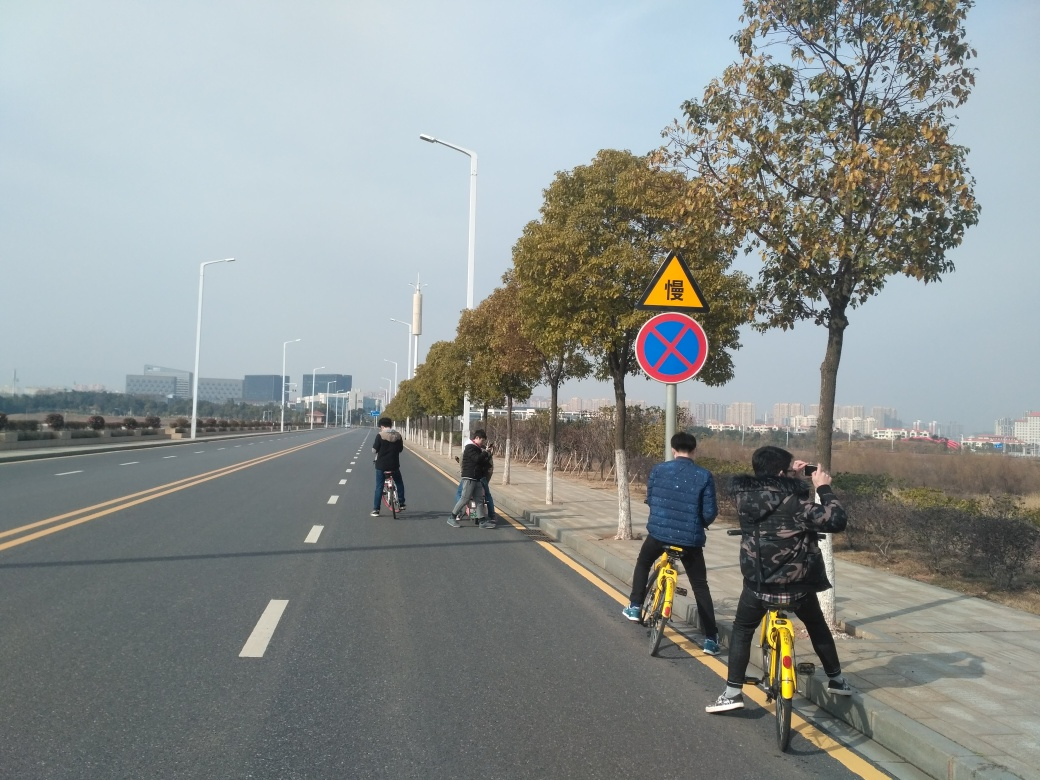Describe the activities of the people in the image. In the image, there are several individuals engaged in various activities. On the right, there is a person taking a photo, capturing the moment or scenery. Meanwhile, on the road, two individuals are seen riding bicycles, likely enjoying a ride along the clear and open road. 